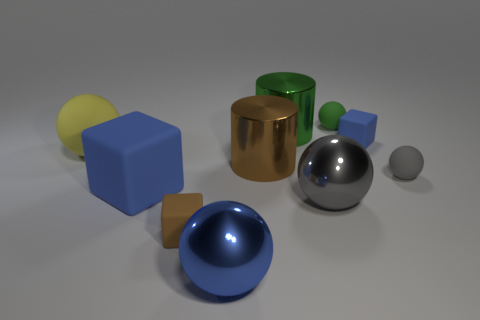How many big blue things are on the right side of the small cube that is in front of the tiny block that is behind the tiny gray rubber thing?
Make the answer very short. 1. There is a brown rubber block; is its size the same as the object that is right of the small blue cube?
Keep it short and to the point. Yes. What size is the blue matte object that is to the left of the tiny block that is behind the big blue rubber object?
Make the answer very short. Large. What number of green things have the same material as the brown cylinder?
Ensure brevity in your answer.  1. Is there a large cyan block?
Offer a terse response. No. There is a blue matte object behind the yellow ball; what is its size?
Make the answer very short. Small. How many tiny rubber cubes are the same color as the large cube?
Ensure brevity in your answer.  1. What number of balls are either yellow rubber objects or small blue shiny things?
Offer a terse response. 1. There is a thing that is behind the large yellow rubber thing and on the left side of the small green sphere; what shape is it?
Ensure brevity in your answer.  Cylinder. Is there a blue rubber object that has the same size as the gray matte sphere?
Make the answer very short. Yes. 